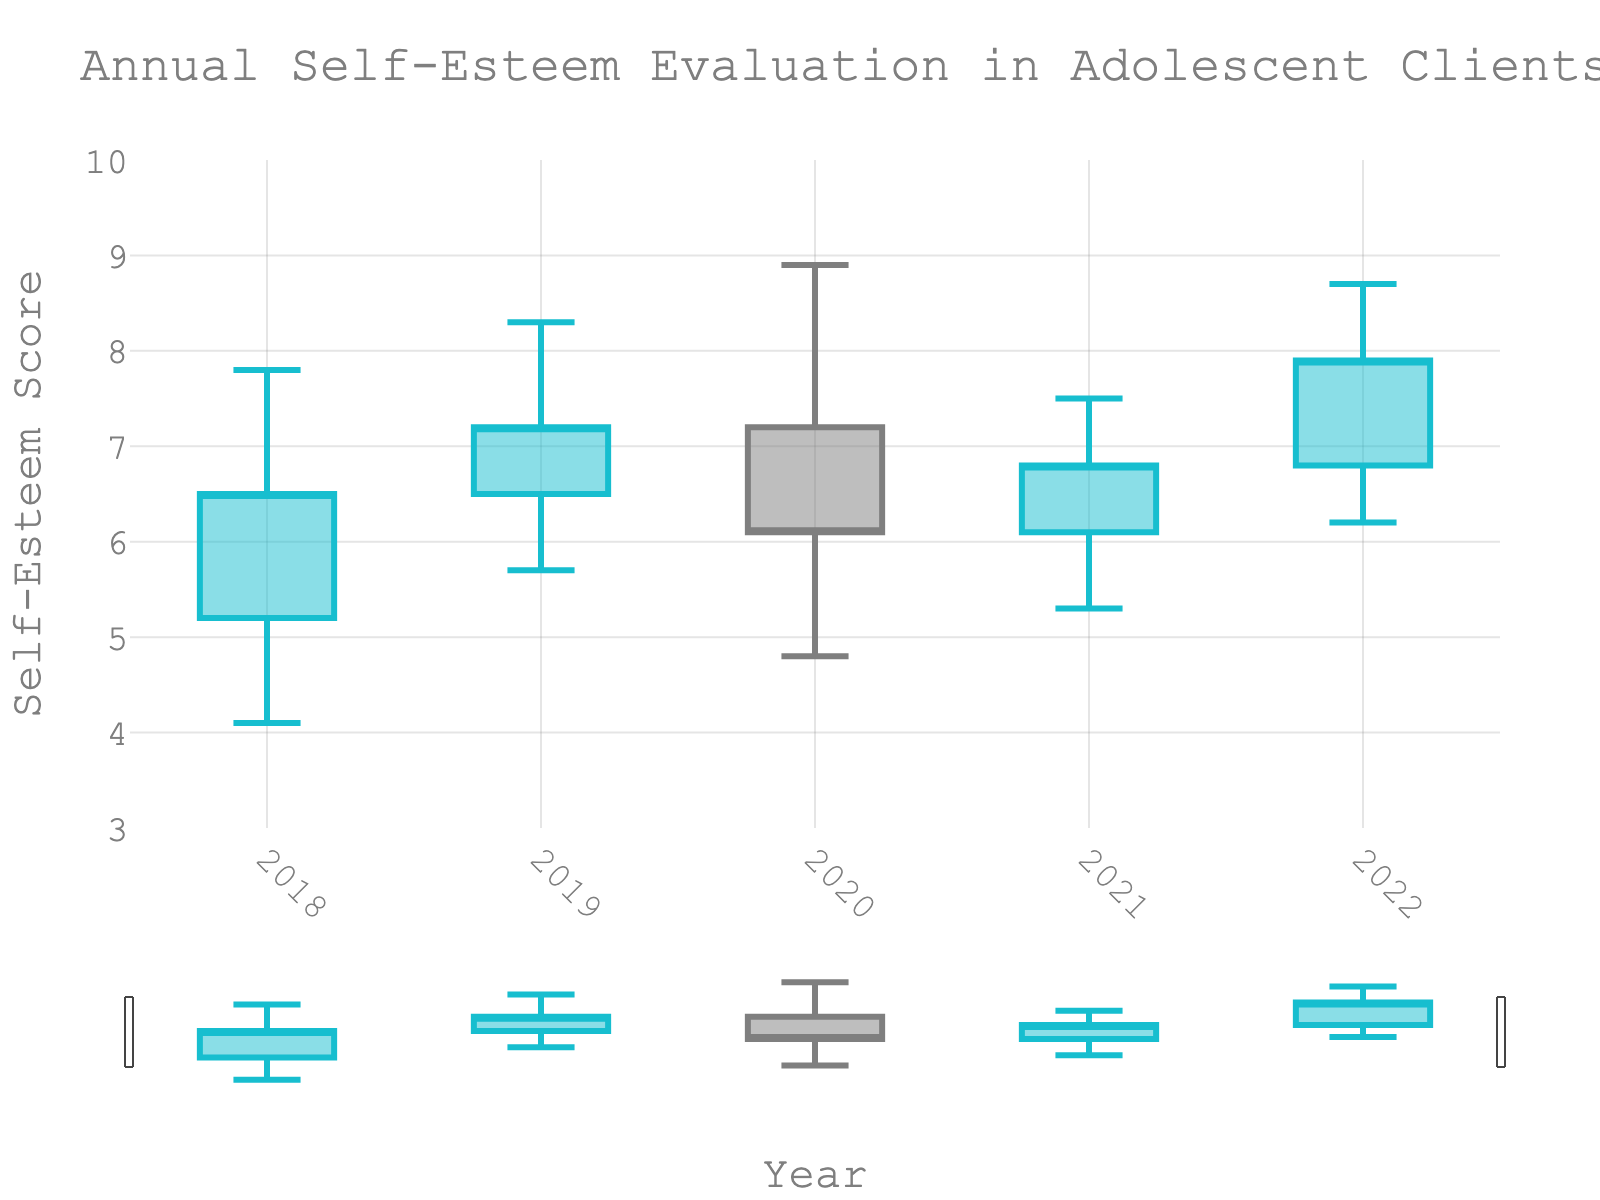What's the title of the chart? The title of the chart is typically displayed prominently at the top of the chart.
Answer: Annual Self-Esteem Evaluation in Adolescent Clients What is the range on the y-axis? Located on the left side of the chart, the y-axis indicates self-esteem scores, which from visual inspection span from 3 to 10.
Answer: 3 to 10 In which year did the self-esteem begin at its highest point? Observing the 'Open' values, the highest initial self-esteem score was in 2020, beginning at 7.2.
Answer: 2020 What is the highest self-esteem score recorded across all years? By examining the 'High' values for each year, the peak score of 8.9 is seen in 2020.
Answer: 8.9 Which year had the largest range in self-esteem scores? The range is found by subtracting the 'Low' value from the 'High' for each year. 2020 has the largest range, as 8.9 - 4.8 = 4.1.
Answer: 2020 Is there a year where the self-esteem ended lower than it started? For this, compare 'Open' and 'Close' values. The year 2020 saw the self-esteem drop from 7.2 to 6.1.
Answer: 2020 What was the lowest point of self-esteem in 2019? The 'Low' value for 2019 was 5.7, as shown on the chart.
Answer: 5.7 Between 2020 and 2021, in which year did self-esteem complete the year higher? Comparing 'Close' values, 2020 ended at 6.1, and 2021 ended at 6.8, so 2021 had a higher year-end score.
Answer: 2021 In which year did the self-esteem score show the least change from beginning to end? The change from 'Open' to 'Close' for each year is calculated, and the smallest difference appears in 2021 (6.1 to 6.8 = 0.7).
Answer: 2021 How does the self-esteem trend look from 2018 to 2022? Observing 'Close' values from 2018 to 2022 (6.5, 7.2, 6.1, 6.8, 7.9), there is a general upward trend with some fluctuations.
Answer: Upward trend 